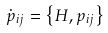Convert formula to latex. <formula><loc_0><loc_0><loc_500><loc_500>\dot { p } _ { i j } = \left \{ H , p _ { i j } \right \}</formula> 